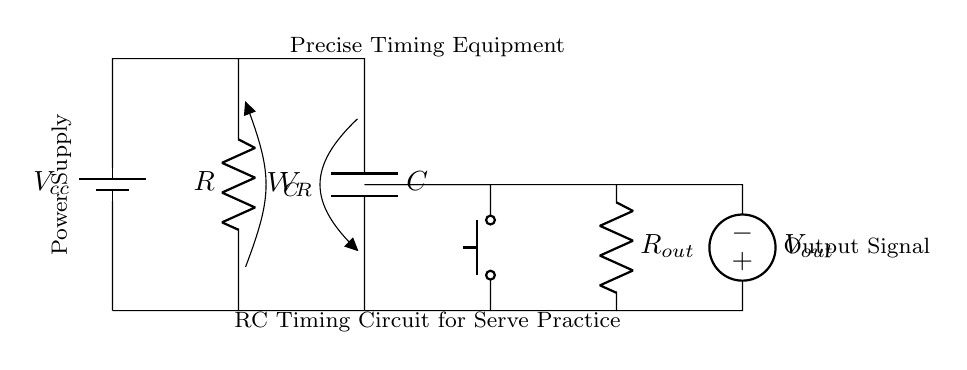What type of circuit is shown? The circuit is an RC timing circuit, which is characterized by a resistor and a capacitor used to create a time delay.
Answer: RC timing circuit What components are used in the circuit? The components in this circuit include a resistor, a capacitor, a battery, and a push button switch. These components are essential for the timing function of the circuit.
Answer: Resistor, Capacitor, Battery, Push Button What is the function of the capacitor in this circuit? The capacitor stores electrical energy and helps determine the timing interval by charging and discharging through the connected resistor, which influences the timing of the output signal.
Answer: Timing interval What happens to the voltage across the capacitor when the button is pressed? When the button is pressed, the capacitor begins to charge up to the supply voltage, resulting in an increase in voltage across it until it reaches a maximum value. This charging characteristic is key in timing applications.
Answer: Increases How does changing the resistor value affect the timing? Increasing the resistance will slow down the charging time of the capacitor, leading to a longer timing interval. Conversely, decreasing the resistance will allow for quicker charging and a shorter timing interval.
Answer: Timing interval changes What is the output voltage when the capacitor is fully charged? The output voltage, when the capacitor is fully charged, is equal to the supply voltage since it acts as an open circuit at steady state.
Answer: Supply voltage 